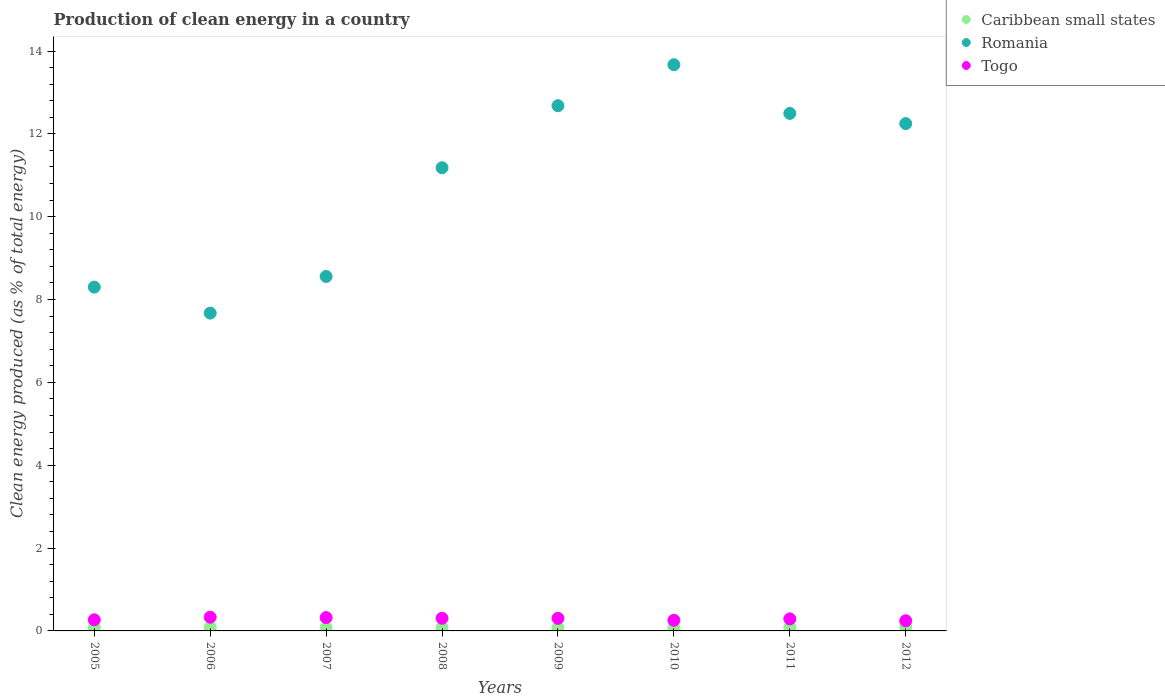Is the number of dotlines equal to the number of legend labels?
Provide a short and direct response. Yes. What is the percentage of clean energy produced in Caribbean small states in 2009?
Your answer should be compact. 0.08. Across all years, what is the maximum percentage of clean energy produced in Togo?
Your answer should be compact. 0.33. Across all years, what is the minimum percentage of clean energy produced in Caribbean small states?
Provide a short and direct response. 0.08. In which year was the percentage of clean energy produced in Togo maximum?
Offer a terse response. 2006. What is the total percentage of clean energy produced in Romania in the graph?
Make the answer very short. 86.8. What is the difference between the percentage of clean energy produced in Romania in 2008 and that in 2012?
Your answer should be compact. -1.07. What is the difference between the percentage of clean energy produced in Togo in 2005 and the percentage of clean energy produced in Caribbean small states in 2008?
Give a very brief answer. 0.19. What is the average percentage of clean energy produced in Caribbean small states per year?
Offer a very short reply. 0.09. In the year 2006, what is the difference between the percentage of clean energy produced in Romania and percentage of clean energy produced in Caribbean small states?
Offer a terse response. 7.59. In how many years, is the percentage of clean energy produced in Caribbean small states greater than 8.4 %?
Provide a short and direct response. 0. What is the ratio of the percentage of clean energy produced in Caribbean small states in 2008 to that in 2011?
Provide a succinct answer. 0.87. Is the difference between the percentage of clean energy produced in Romania in 2006 and 2008 greater than the difference between the percentage of clean energy produced in Caribbean small states in 2006 and 2008?
Your answer should be compact. No. What is the difference between the highest and the second highest percentage of clean energy produced in Romania?
Provide a succinct answer. 0.99. What is the difference between the highest and the lowest percentage of clean energy produced in Romania?
Provide a short and direct response. 6. In how many years, is the percentage of clean energy produced in Togo greater than the average percentage of clean energy produced in Togo taken over all years?
Give a very brief answer. 5. Does the percentage of clean energy produced in Romania monotonically increase over the years?
Provide a short and direct response. No. What is the difference between two consecutive major ticks on the Y-axis?
Keep it short and to the point. 2. Are the values on the major ticks of Y-axis written in scientific E-notation?
Provide a succinct answer. No. Where does the legend appear in the graph?
Provide a short and direct response. Top right. How many legend labels are there?
Ensure brevity in your answer.  3. How are the legend labels stacked?
Offer a very short reply. Vertical. What is the title of the graph?
Offer a terse response. Production of clean energy in a country. What is the label or title of the X-axis?
Ensure brevity in your answer.  Years. What is the label or title of the Y-axis?
Your answer should be very brief. Clean energy produced (as % of total energy). What is the Clean energy produced (as % of total energy) in Caribbean small states in 2005?
Provide a short and direct response. 0.09. What is the Clean energy produced (as % of total energy) of Romania in 2005?
Offer a terse response. 8.3. What is the Clean energy produced (as % of total energy) in Togo in 2005?
Keep it short and to the point. 0.27. What is the Clean energy produced (as % of total energy) of Caribbean small states in 2006?
Ensure brevity in your answer.  0.09. What is the Clean energy produced (as % of total energy) of Romania in 2006?
Offer a terse response. 7.67. What is the Clean energy produced (as % of total energy) in Togo in 2006?
Keep it short and to the point. 0.33. What is the Clean energy produced (as % of total energy) in Caribbean small states in 2007?
Your answer should be compact. 0.08. What is the Clean energy produced (as % of total energy) in Romania in 2007?
Provide a short and direct response. 8.56. What is the Clean energy produced (as % of total energy) of Togo in 2007?
Keep it short and to the point. 0.32. What is the Clean energy produced (as % of total energy) in Caribbean small states in 2008?
Give a very brief answer. 0.08. What is the Clean energy produced (as % of total energy) of Romania in 2008?
Your answer should be compact. 11.18. What is the Clean energy produced (as % of total energy) in Togo in 2008?
Ensure brevity in your answer.  0.31. What is the Clean energy produced (as % of total energy) of Caribbean small states in 2009?
Offer a terse response. 0.08. What is the Clean energy produced (as % of total energy) of Romania in 2009?
Offer a terse response. 12.68. What is the Clean energy produced (as % of total energy) in Togo in 2009?
Offer a terse response. 0.3. What is the Clean energy produced (as % of total energy) in Caribbean small states in 2010?
Keep it short and to the point. 0.08. What is the Clean energy produced (as % of total energy) in Romania in 2010?
Give a very brief answer. 13.67. What is the Clean energy produced (as % of total energy) of Togo in 2010?
Your answer should be compact. 0.26. What is the Clean energy produced (as % of total energy) in Caribbean small states in 2011?
Give a very brief answer. 0.09. What is the Clean energy produced (as % of total energy) of Romania in 2011?
Ensure brevity in your answer.  12.49. What is the Clean energy produced (as % of total energy) in Togo in 2011?
Offer a terse response. 0.29. What is the Clean energy produced (as % of total energy) in Caribbean small states in 2012?
Provide a short and direct response. 0.1. What is the Clean energy produced (as % of total energy) in Romania in 2012?
Your answer should be compact. 12.25. What is the Clean energy produced (as % of total energy) in Togo in 2012?
Your answer should be compact. 0.25. Across all years, what is the maximum Clean energy produced (as % of total energy) in Caribbean small states?
Keep it short and to the point. 0.1. Across all years, what is the maximum Clean energy produced (as % of total energy) of Romania?
Your response must be concise. 13.67. Across all years, what is the maximum Clean energy produced (as % of total energy) of Togo?
Give a very brief answer. 0.33. Across all years, what is the minimum Clean energy produced (as % of total energy) of Caribbean small states?
Give a very brief answer. 0.08. Across all years, what is the minimum Clean energy produced (as % of total energy) of Romania?
Your answer should be very brief. 7.67. Across all years, what is the minimum Clean energy produced (as % of total energy) in Togo?
Keep it short and to the point. 0.25. What is the total Clean energy produced (as % of total energy) of Caribbean small states in the graph?
Ensure brevity in your answer.  0.68. What is the total Clean energy produced (as % of total energy) in Romania in the graph?
Give a very brief answer. 86.8. What is the total Clean energy produced (as % of total energy) of Togo in the graph?
Keep it short and to the point. 2.32. What is the difference between the Clean energy produced (as % of total energy) of Caribbean small states in 2005 and that in 2006?
Keep it short and to the point. 0. What is the difference between the Clean energy produced (as % of total energy) in Romania in 2005 and that in 2006?
Make the answer very short. 0.63. What is the difference between the Clean energy produced (as % of total energy) in Togo in 2005 and that in 2006?
Make the answer very short. -0.06. What is the difference between the Clean energy produced (as % of total energy) of Caribbean small states in 2005 and that in 2007?
Keep it short and to the point. 0.01. What is the difference between the Clean energy produced (as % of total energy) of Romania in 2005 and that in 2007?
Your response must be concise. -0.26. What is the difference between the Clean energy produced (as % of total energy) of Togo in 2005 and that in 2007?
Offer a very short reply. -0.05. What is the difference between the Clean energy produced (as % of total energy) of Caribbean small states in 2005 and that in 2008?
Keep it short and to the point. 0.01. What is the difference between the Clean energy produced (as % of total energy) in Romania in 2005 and that in 2008?
Your answer should be compact. -2.88. What is the difference between the Clean energy produced (as % of total energy) of Togo in 2005 and that in 2008?
Provide a succinct answer. -0.04. What is the difference between the Clean energy produced (as % of total energy) of Caribbean small states in 2005 and that in 2009?
Make the answer very short. 0.01. What is the difference between the Clean energy produced (as % of total energy) of Romania in 2005 and that in 2009?
Your response must be concise. -4.38. What is the difference between the Clean energy produced (as % of total energy) in Togo in 2005 and that in 2009?
Provide a short and direct response. -0.04. What is the difference between the Clean energy produced (as % of total energy) in Caribbean small states in 2005 and that in 2010?
Provide a succinct answer. 0.01. What is the difference between the Clean energy produced (as % of total energy) in Romania in 2005 and that in 2010?
Your answer should be very brief. -5.37. What is the difference between the Clean energy produced (as % of total energy) of Togo in 2005 and that in 2010?
Your answer should be compact. 0.01. What is the difference between the Clean energy produced (as % of total energy) in Caribbean small states in 2005 and that in 2011?
Offer a terse response. -0. What is the difference between the Clean energy produced (as % of total energy) in Romania in 2005 and that in 2011?
Keep it short and to the point. -4.19. What is the difference between the Clean energy produced (as % of total energy) in Togo in 2005 and that in 2011?
Give a very brief answer. -0.02. What is the difference between the Clean energy produced (as % of total energy) of Caribbean small states in 2005 and that in 2012?
Offer a terse response. -0.01. What is the difference between the Clean energy produced (as % of total energy) of Romania in 2005 and that in 2012?
Offer a very short reply. -3.95. What is the difference between the Clean energy produced (as % of total energy) in Togo in 2005 and that in 2012?
Your answer should be compact. 0.02. What is the difference between the Clean energy produced (as % of total energy) in Caribbean small states in 2006 and that in 2007?
Give a very brief answer. 0.01. What is the difference between the Clean energy produced (as % of total energy) in Romania in 2006 and that in 2007?
Offer a very short reply. -0.88. What is the difference between the Clean energy produced (as % of total energy) in Togo in 2006 and that in 2007?
Provide a succinct answer. 0.01. What is the difference between the Clean energy produced (as % of total energy) in Caribbean small states in 2006 and that in 2008?
Make the answer very short. 0.01. What is the difference between the Clean energy produced (as % of total energy) of Romania in 2006 and that in 2008?
Your response must be concise. -3.51. What is the difference between the Clean energy produced (as % of total energy) in Togo in 2006 and that in 2008?
Provide a short and direct response. 0.03. What is the difference between the Clean energy produced (as % of total energy) of Caribbean small states in 2006 and that in 2009?
Keep it short and to the point. 0.01. What is the difference between the Clean energy produced (as % of total energy) in Romania in 2006 and that in 2009?
Give a very brief answer. -5.01. What is the difference between the Clean energy produced (as % of total energy) in Togo in 2006 and that in 2009?
Provide a short and direct response. 0.03. What is the difference between the Clean energy produced (as % of total energy) of Caribbean small states in 2006 and that in 2010?
Provide a short and direct response. 0.01. What is the difference between the Clean energy produced (as % of total energy) of Romania in 2006 and that in 2010?
Provide a succinct answer. -6. What is the difference between the Clean energy produced (as % of total energy) of Togo in 2006 and that in 2010?
Your answer should be compact. 0.07. What is the difference between the Clean energy produced (as % of total energy) of Caribbean small states in 2006 and that in 2011?
Keep it short and to the point. -0.01. What is the difference between the Clean energy produced (as % of total energy) of Romania in 2006 and that in 2011?
Your response must be concise. -4.82. What is the difference between the Clean energy produced (as % of total energy) in Togo in 2006 and that in 2011?
Keep it short and to the point. 0.04. What is the difference between the Clean energy produced (as % of total energy) in Caribbean small states in 2006 and that in 2012?
Provide a succinct answer. -0.01. What is the difference between the Clean energy produced (as % of total energy) of Romania in 2006 and that in 2012?
Provide a succinct answer. -4.57. What is the difference between the Clean energy produced (as % of total energy) of Togo in 2006 and that in 2012?
Keep it short and to the point. 0.09. What is the difference between the Clean energy produced (as % of total energy) in Caribbean small states in 2007 and that in 2008?
Your answer should be compact. -0. What is the difference between the Clean energy produced (as % of total energy) of Romania in 2007 and that in 2008?
Your response must be concise. -2.63. What is the difference between the Clean energy produced (as % of total energy) of Togo in 2007 and that in 2008?
Keep it short and to the point. 0.02. What is the difference between the Clean energy produced (as % of total energy) of Caribbean small states in 2007 and that in 2009?
Offer a very short reply. -0. What is the difference between the Clean energy produced (as % of total energy) of Romania in 2007 and that in 2009?
Provide a succinct answer. -4.12. What is the difference between the Clean energy produced (as % of total energy) of Togo in 2007 and that in 2009?
Make the answer very short. 0.02. What is the difference between the Clean energy produced (as % of total energy) of Caribbean small states in 2007 and that in 2010?
Your response must be concise. 0. What is the difference between the Clean energy produced (as % of total energy) of Romania in 2007 and that in 2010?
Provide a short and direct response. -5.11. What is the difference between the Clean energy produced (as % of total energy) of Togo in 2007 and that in 2010?
Keep it short and to the point. 0.07. What is the difference between the Clean energy produced (as % of total energy) in Caribbean small states in 2007 and that in 2011?
Provide a short and direct response. -0.01. What is the difference between the Clean energy produced (as % of total energy) in Romania in 2007 and that in 2011?
Make the answer very short. -3.94. What is the difference between the Clean energy produced (as % of total energy) in Togo in 2007 and that in 2011?
Your answer should be compact. 0.03. What is the difference between the Clean energy produced (as % of total energy) in Caribbean small states in 2007 and that in 2012?
Offer a terse response. -0.02. What is the difference between the Clean energy produced (as % of total energy) of Romania in 2007 and that in 2012?
Offer a very short reply. -3.69. What is the difference between the Clean energy produced (as % of total energy) of Togo in 2007 and that in 2012?
Keep it short and to the point. 0.08. What is the difference between the Clean energy produced (as % of total energy) of Caribbean small states in 2008 and that in 2009?
Ensure brevity in your answer.  0. What is the difference between the Clean energy produced (as % of total energy) of Romania in 2008 and that in 2009?
Provide a succinct answer. -1.5. What is the difference between the Clean energy produced (as % of total energy) of Togo in 2008 and that in 2009?
Keep it short and to the point. 0. What is the difference between the Clean energy produced (as % of total energy) of Caribbean small states in 2008 and that in 2010?
Provide a succinct answer. 0. What is the difference between the Clean energy produced (as % of total energy) of Romania in 2008 and that in 2010?
Offer a terse response. -2.49. What is the difference between the Clean energy produced (as % of total energy) in Togo in 2008 and that in 2010?
Offer a terse response. 0.05. What is the difference between the Clean energy produced (as % of total energy) of Caribbean small states in 2008 and that in 2011?
Provide a short and direct response. -0.01. What is the difference between the Clean energy produced (as % of total energy) of Romania in 2008 and that in 2011?
Your answer should be very brief. -1.31. What is the difference between the Clean energy produced (as % of total energy) of Togo in 2008 and that in 2011?
Your answer should be compact. 0.01. What is the difference between the Clean energy produced (as % of total energy) of Caribbean small states in 2008 and that in 2012?
Provide a short and direct response. -0.02. What is the difference between the Clean energy produced (as % of total energy) in Romania in 2008 and that in 2012?
Make the answer very short. -1.07. What is the difference between the Clean energy produced (as % of total energy) in Togo in 2008 and that in 2012?
Ensure brevity in your answer.  0.06. What is the difference between the Clean energy produced (as % of total energy) in Romania in 2009 and that in 2010?
Give a very brief answer. -0.99. What is the difference between the Clean energy produced (as % of total energy) in Togo in 2009 and that in 2010?
Provide a short and direct response. 0.05. What is the difference between the Clean energy produced (as % of total energy) of Caribbean small states in 2009 and that in 2011?
Your answer should be very brief. -0.01. What is the difference between the Clean energy produced (as % of total energy) in Romania in 2009 and that in 2011?
Provide a short and direct response. 0.19. What is the difference between the Clean energy produced (as % of total energy) of Togo in 2009 and that in 2011?
Provide a succinct answer. 0.01. What is the difference between the Clean energy produced (as % of total energy) of Caribbean small states in 2009 and that in 2012?
Your answer should be compact. -0.02. What is the difference between the Clean energy produced (as % of total energy) in Romania in 2009 and that in 2012?
Ensure brevity in your answer.  0.43. What is the difference between the Clean energy produced (as % of total energy) in Togo in 2009 and that in 2012?
Offer a terse response. 0.06. What is the difference between the Clean energy produced (as % of total energy) in Caribbean small states in 2010 and that in 2011?
Your response must be concise. -0.01. What is the difference between the Clean energy produced (as % of total energy) of Romania in 2010 and that in 2011?
Ensure brevity in your answer.  1.18. What is the difference between the Clean energy produced (as % of total energy) in Togo in 2010 and that in 2011?
Ensure brevity in your answer.  -0.03. What is the difference between the Clean energy produced (as % of total energy) in Caribbean small states in 2010 and that in 2012?
Your answer should be compact. -0.02. What is the difference between the Clean energy produced (as % of total energy) of Romania in 2010 and that in 2012?
Give a very brief answer. 1.42. What is the difference between the Clean energy produced (as % of total energy) in Togo in 2010 and that in 2012?
Your answer should be very brief. 0.01. What is the difference between the Clean energy produced (as % of total energy) of Caribbean small states in 2011 and that in 2012?
Keep it short and to the point. -0.01. What is the difference between the Clean energy produced (as % of total energy) in Romania in 2011 and that in 2012?
Provide a short and direct response. 0.25. What is the difference between the Clean energy produced (as % of total energy) of Togo in 2011 and that in 2012?
Make the answer very short. 0.05. What is the difference between the Clean energy produced (as % of total energy) of Caribbean small states in 2005 and the Clean energy produced (as % of total energy) of Romania in 2006?
Provide a succinct answer. -7.59. What is the difference between the Clean energy produced (as % of total energy) in Caribbean small states in 2005 and the Clean energy produced (as % of total energy) in Togo in 2006?
Give a very brief answer. -0.24. What is the difference between the Clean energy produced (as % of total energy) of Romania in 2005 and the Clean energy produced (as % of total energy) of Togo in 2006?
Offer a terse response. 7.97. What is the difference between the Clean energy produced (as % of total energy) in Caribbean small states in 2005 and the Clean energy produced (as % of total energy) in Romania in 2007?
Provide a short and direct response. -8.47. What is the difference between the Clean energy produced (as % of total energy) of Caribbean small states in 2005 and the Clean energy produced (as % of total energy) of Togo in 2007?
Keep it short and to the point. -0.23. What is the difference between the Clean energy produced (as % of total energy) of Romania in 2005 and the Clean energy produced (as % of total energy) of Togo in 2007?
Your response must be concise. 7.98. What is the difference between the Clean energy produced (as % of total energy) of Caribbean small states in 2005 and the Clean energy produced (as % of total energy) of Romania in 2008?
Your answer should be compact. -11.09. What is the difference between the Clean energy produced (as % of total energy) of Caribbean small states in 2005 and the Clean energy produced (as % of total energy) of Togo in 2008?
Provide a short and direct response. -0.22. What is the difference between the Clean energy produced (as % of total energy) of Romania in 2005 and the Clean energy produced (as % of total energy) of Togo in 2008?
Provide a short and direct response. 7.99. What is the difference between the Clean energy produced (as % of total energy) of Caribbean small states in 2005 and the Clean energy produced (as % of total energy) of Romania in 2009?
Ensure brevity in your answer.  -12.59. What is the difference between the Clean energy produced (as % of total energy) in Caribbean small states in 2005 and the Clean energy produced (as % of total energy) in Togo in 2009?
Keep it short and to the point. -0.22. What is the difference between the Clean energy produced (as % of total energy) in Romania in 2005 and the Clean energy produced (as % of total energy) in Togo in 2009?
Ensure brevity in your answer.  8. What is the difference between the Clean energy produced (as % of total energy) of Caribbean small states in 2005 and the Clean energy produced (as % of total energy) of Romania in 2010?
Your answer should be compact. -13.58. What is the difference between the Clean energy produced (as % of total energy) in Caribbean small states in 2005 and the Clean energy produced (as % of total energy) in Togo in 2010?
Provide a short and direct response. -0.17. What is the difference between the Clean energy produced (as % of total energy) of Romania in 2005 and the Clean energy produced (as % of total energy) of Togo in 2010?
Offer a very short reply. 8.04. What is the difference between the Clean energy produced (as % of total energy) of Caribbean small states in 2005 and the Clean energy produced (as % of total energy) of Romania in 2011?
Your response must be concise. -12.41. What is the difference between the Clean energy produced (as % of total energy) in Caribbean small states in 2005 and the Clean energy produced (as % of total energy) in Togo in 2011?
Provide a succinct answer. -0.2. What is the difference between the Clean energy produced (as % of total energy) in Romania in 2005 and the Clean energy produced (as % of total energy) in Togo in 2011?
Make the answer very short. 8.01. What is the difference between the Clean energy produced (as % of total energy) in Caribbean small states in 2005 and the Clean energy produced (as % of total energy) in Romania in 2012?
Offer a terse response. -12.16. What is the difference between the Clean energy produced (as % of total energy) of Caribbean small states in 2005 and the Clean energy produced (as % of total energy) of Togo in 2012?
Keep it short and to the point. -0.16. What is the difference between the Clean energy produced (as % of total energy) in Romania in 2005 and the Clean energy produced (as % of total energy) in Togo in 2012?
Provide a short and direct response. 8.05. What is the difference between the Clean energy produced (as % of total energy) in Caribbean small states in 2006 and the Clean energy produced (as % of total energy) in Romania in 2007?
Your answer should be compact. -8.47. What is the difference between the Clean energy produced (as % of total energy) of Caribbean small states in 2006 and the Clean energy produced (as % of total energy) of Togo in 2007?
Provide a short and direct response. -0.24. What is the difference between the Clean energy produced (as % of total energy) in Romania in 2006 and the Clean energy produced (as % of total energy) in Togo in 2007?
Make the answer very short. 7.35. What is the difference between the Clean energy produced (as % of total energy) of Caribbean small states in 2006 and the Clean energy produced (as % of total energy) of Romania in 2008?
Offer a terse response. -11.1. What is the difference between the Clean energy produced (as % of total energy) in Caribbean small states in 2006 and the Clean energy produced (as % of total energy) in Togo in 2008?
Your answer should be very brief. -0.22. What is the difference between the Clean energy produced (as % of total energy) of Romania in 2006 and the Clean energy produced (as % of total energy) of Togo in 2008?
Your answer should be compact. 7.37. What is the difference between the Clean energy produced (as % of total energy) of Caribbean small states in 2006 and the Clean energy produced (as % of total energy) of Romania in 2009?
Give a very brief answer. -12.59. What is the difference between the Clean energy produced (as % of total energy) in Caribbean small states in 2006 and the Clean energy produced (as % of total energy) in Togo in 2009?
Ensure brevity in your answer.  -0.22. What is the difference between the Clean energy produced (as % of total energy) of Romania in 2006 and the Clean energy produced (as % of total energy) of Togo in 2009?
Your answer should be very brief. 7.37. What is the difference between the Clean energy produced (as % of total energy) of Caribbean small states in 2006 and the Clean energy produced (as % of total energy) of Romania in 2010?
Give a very brief answer. -13.58. What is the difference between the Clean energy produced (as % of total energy) of Caribbean small states in 2006 and the Clean energy produced (as % of total energy) of Togo in 2010?
Ensure brevity in your answer.  -0.17. What is the difference between the Clean energy produced (as % of total energy) of Romania in 2006 and the Clean energy produced (as % of total energy) of Togo in 2010?
Offer a terse response. 7.42. What is the difference between the Clean energy produced (as % of total energy) of Caribbean small states in 2006 and the Clean energy produced (as % of total energy) of Romania in 2011?
Your answer should be compact. -12.41. What is the difference between the Clean energy produced (as % of total energy) in Caribbean small states in 2006 and the Clean energy produced (as % of total energy) in Togo in 2011?
Your answer should be compact. -0.21. What is the difference between the Clean energy produced (as % of total energy) of Romania in 2006 and the Clean energy produced (as % of total energy) of Togo in 2011?
Keep it short and to the point. 7.38. What is the difference between the Clean energy produced (as % of total energy) in Caribbean small states in 2006 and the Clean energy produced (as % of total energy) in Romania in 2012?
Your answer should be very brief. -12.16. What is the difference between the Clean energy produced (as % of total energy) in Caribbean small states in 2006 and the Clean energy produced (as % of total energy) in Togo in 2012?
Provide a short and direct response. -0.16. What is the difference between the Clean energy produced (as % of total energy) in Romania in 2006 and the Clean energy produced (as % of total energy) in Togo in 2012?
Your answer should be compact. 7.43. What is the difference between the Clean energy produced (as % of total energy) in Caribbean small states in 2007 and the Clean energy produced (as % of total energy) in Romania in 2008?
Your response must be concise. -11.1. What is the difference between the Clean energy produced (as % of total energy) in Caribbean small states in 2007 and the Clean energy produced (as % of total energy) in Togo in 2008?
Give a very brief answer. -0.23. What is the difference between the Clean energy produced (as % of total energy) in Romania in 2007 and the Clean energy produced (as % of total energy) in Togo in 2008?
Provide a short and direct response. 8.25. What is the difference between the Clean energy produced (as % of total energy) in Caribbean small states in 2007 and the Clean energy produced (as % of total energy) in Romania in 2009?
Ensure brevity in your answer.  -12.6. What is the difference between the Clean energy produced (as % of total energy) in Caribbean small states in 2007 and the Clean energy produced (as % of total energy) in Togo in 2009?
Provide a short and direct response. -0.23. What is the difference between the Clean energy produced (as % of total energy) of Romania in 2007 and the Clean energy produced (as % of total energy) of Togo in 2009?
Provide a succinct answer. 8.25. What is the difference between the Clean energy produced (as % of total energy) of Caribbean small states in 2007 and the Clean energy produced (as % of total energy) of Romania in 2010?
Your answer should be compact. -13.59. What is the difference between the Clean energy produced (as % of total energy) in Caribbean small states in 2007 and the Clean energy produced (as % of total energy) in Togo in 2010?
Your response must be concise. -0.18. What is the difference between the Clean energy produced (as % of total energy) in Romania in 2007 and the Clean energy produced (as % of total energy) in Togo in 2010?
Provide a short and direct response. 8.3. What is the difference between the Clean energy produced (as % of total energy) in Caribbean small states in 2007 and the Clean energy produced (as % of total energy) in Romania in 2011?
Keep it short and to the point. -12.42. What is the difference between the Clean energy produced (as % of total energy) in Caribbean small states in 2007 and the Clean energy produced (as % of total energy) in Togo in 2011?
Ensure brevity in your answer.  -0.21. What is the difference between the Clean energy produced (as % of total energy) in Romania in 2007 and the Clean energy produced (as % of total energy) in Togo in 2011?
Your response must be concise. 8.27. What is the difference between the Clean energy produced (as % of total energy) in Caribbean small states in 2007 and the Clean energy produced (as % of total energy) in Romania in 2012?
Ensure brevity in your answer.  -12.17. What is the difference between the Clean energy produced (as % of total energy) of Caribbean small states in 2007 and the Clean energy produced (as % of total energy) of Togo in 2012?
Offer a very short reply. -0.17. What is the difference between the Clean energy produced (as % of total energy) in Romania in 2007 and the Clean energy produced (as % of total energy) in Togo in 2012?
Keep it short and to the point. 8.31. What is the difference between the Clean energy produced (as % of total energy) of Caribbean small states in 2008 and the Clean energy produced (as % of total energy) of Romania in 2009?
Your answer should be very brief. -12.6. What is the difference between the Clean energy produced (as % of total energy) of Caribbean small states in 2008 and the Clean energy produced (as % of total energy) of Togo in 2009?
Make the answer very short. -0.22. What is the difference between the Clean energy produced (as % of total energy) of Romania in 2008 and the Clean energy produced (as % of total energy) of Togo in 2009?
Make the answer very short. 10.88. What is the difference between the Clean energy produced (as % of total energy) of Caribbean small states in 2008 and the Clean energy produced (as % of total energy) of Romania in 2010?
Offer a very short reply. -13.59. What is the difference between the Clean energy produced (as % of total energy) in Caribbean small states in 2008 and the Clean energy produced (as % of total energy) in Togo in 2010?
Give a very brief answer. -0.18. What is the difference between the Clean energy produced (as % of total energy) of Romania in 2008 and the Clean energy produced (as % of total energy) of Togo in 2010?
Ensure brevity in your answer.  10.93. What is the difference between the Clean energy produced (as % of total energy) of Caribbean small states in 2008 and the Clean energy produced (as % of total energy) of Romania in 2011?
Provide a succinct answer. -12.41. What is the difference between the Clean energy produced (as % of total energy) in Caribbean small states in 2008 and the Clean energy produced (as % of total energy) in Togo in 2011?
Give a very brief answer. -0.21. What is the difference between the Clean energy produced (as % of total energy) of Romania in 2008 and the Clean energy produced (as % of total energy) of Togo in 2011?
Your answer should be compact. 10.89. What is the difference between the Clean energy produced (as % of total energy) of Caribbean small states in 2008 and the Clean energy produced (as % of total energy) of Romania in 2012?
Keep it short and to the point. -12.17. What is the difference between the Clean energy produced (as % of total energy) in Caribbean small states in 2008 and the Clean energy produced (as % of total energy) in Togo in 2012?
Provide a succinct answer. -0.16. What is the difference between the Clean energy produced (as % of total energy) in Romania in 2008 and the Clean energy produced (as % of total energy) in Togo in 2012?
Offer a terse response. 10.94. What is the difference between the Clean energy produced (as % of total energy) in Caribbean small states in 2009 and the Clean energy produced (as % of total energy) in Romania in 2010?
Your response must be concise. -13.59. What is the difference between the Clean energy produced (as % of total energy) of Caribbean small states in 2009 and the Clean energy produced (as % of total energy) of Togo in 2010?
Your answer should be compact. -0.18. What is the difference between the Clean energy produced (as % of total energy) of Romania in 2009 and the Clean energy produced (as % of total energy) of Togo in 2010?
Make the answer very short. 12.42. What is the difference between the Clean energy produced (as % of total energy) of Caribbean small states in 2009 and the Clean energy produced (as % of total energy) of Romania in 2011?
Offer a terse response. -12.42. What is the difference between the Clean energy produced (as % of total energy) of Caribbean small states in 2009 and the Clean energy produced (as % of total energy) of Togo in 2011?
Ensure brevity in your answer.  -0.21. What is the difference between the Clean energy produced (as % of total energy) of Romania in 2009 and the Clean energy produced (as % of total energy) of Togo in 2011?
Give a very brief answer. 12.39. What is the difference between the Clean energy produced (as % of total energy) of Caribbean small states in 2009 and the Clean energy produced (as % of total energy) of Romania in 2012?
Make the answer very short. -12.17. What is the difference between the Clean energy produced (as % of total energy) in Caribbean small states in 2009 and the Clean energy produced (as % of total energy) in Togo in 2012?
Offer a very short reply. -0.17. What is the difference between the Clean energy produced (as % of total energy) of Romania in 2009 and the Clean energy produced (as % of total energy) of Togo in 2012?
Make the answer very short. 12.43. What is the difference between the Clean energy produced (as % of total energy) of Caribbean small states in 2010 and the Clean energy produced (as % of total energy) of Romania in 2011?
Your answer should be compact. -12.42. What is the difference between the Clean energy produced (as % of total energy) in Caribbean small states in 2010 and the Clean energy produced (as % of total energy) in Togo in 2011?
Provide a short and direct response. -0.21. What is the difference between the Clean energy produced (as % of total energy) in Romania in 2010 and the Clean energy produced (as % of total energy) in Togo in 2011?
Give a very brief answer. 13.38. What is the difference between the Clean energy produced (as % of total energy) in Caribbean small states in 2010 and the Clean energy produced (as % of total energy) in Romania in 2012?
Your answer should be very brief. -12.17. What is the difference between the Clean energy produced (as % of total energy) of Caribbean small states in 2010 and the Clean energy produced (as % of total energy) of Togo in 2012?
Keep it short and to the point. -0.17. What is the difference between the Clean energy produced (as % of total energy) of Romania in 2010 and the Clean energy produced (as % of total energy) of Togo in 2012?
Make the answer very short. 13.42. What is the difference between the Clean energy produced (as % of total energy) in Caribbean small states in 2011 and the Clean energy produced (as % of total energy) in Romania in 2012?
Give a very brief answer. -12.16. What is the difference between the Clean energy produced (as % of total energy) in Caribbean small states in 2011 and the Clean energy produced (as % of total energy) in Togo in 2012?
Give a very brief answer. -0.15. What is the difference between the Clean energy produced (as % of total energy) of Romania in 2011 and the Clean energy produced (as % of total energy) of Togo in 2012?
Keep it short and to the point. 12.25. What is the average Clean energy produced (as % of total energy) in Caribbean small states per year?
Your answer should be compact. 0.09. What is the average Clean energy produced (as % of total energy) in Romania per year?
Your response must be concise. 10.85. What is the average Clean energy produced (as % of total energy) of Togo per year?
Give a very brief answer. 0.29. In the year 2005, what is the difference between the Clean energy produced (as % of total energy) in Caribbean small states and Clean energy produced (as % of total energy) in Romania?
Make the answer very short. -8.21. In the year 2005, what is the difference between the Clean energy produced (as % of total energy) in Caribbean small states and Clean energy produced (as % of total energy) in Togo?
Offer a very short reply. -0.18. In the year 2005, what is the difference between the Clean energy produced (as % of total energy) of Romania and Clean energy produced (as % of total energy) of Togo?
Keep it short and to the point. 8.03. In the year 2006, what is the difference between the Clean energy produced (as % of total energy) in Caribbean small states and Clean energy produced (as % of total energy) in Romania?
Ensure brevity in your answer.  -7.59. In the year 2006, what is the difference between the Clean energy produced (as % of total energy) of Caribbean small states and Clean energy produced (as % of total energy) of Togo?
Keep it short and to the point. -0.24. In the year 2006, what is the difference between the Clean energy produced (as % of total energy) of Romania and Clean energy produced (as % of total energy) of Togo?
Your response must be concise. 7.34. In the year 2007, what is the difference between the Clean energy produced (as % of total energy) of Caribbean small states and Clean energy produced (as % of total energy) of Romania?
Your answer should be very brief. -8.48. In the year 2007, what is the difference between the Clean energy produced (as % of total energy) of Caribbean small states and Clean energy produced (as % of total energy) of Togo?
Offer a terse response. -0.24. In the year 2007, what is the difference between the Clean energy produced (as % of total energy) in Romania and Clean energy produced (as % of total energy) in Togo?
Your answer should be compact. 8.23. In the year 2008, what is the difference between the Clean energy produced (as % of total energy) of Caribbean small states and Clean energy produced (as % of total energy) of Romania?
Offer a very short reply. -11.1. In the year 2008, what is the difference between the Clean energy produced (as % of total energy) in Caribbean small states and Clean energy produced (as % of total energy) in Togo?
Offer a terse response. -0.23. In the year 2008, what is the difference between the Clean energy produced (as % of total energy) in Romania and Clean energy produced (as % of total energy) in Togo?
Your answer should be very brief. 10.88. In the year 2009, what is the difference between the Clean energy produced (as % of total energy) of Caribbean small states and Clean energy produced (as % of total energy) of Romania?
Ensure brevity in your answer.  -12.6. In the year 2009, what is the difference between the Clean energy produced (as % of total energy) in Caribbean small states and Clean energy produced (as % of total energy) in Togo?
Make the answer very short. -0.23. In the year 2009, what is the difference between the Clean energy produced (as % of total energy) in Romania and Clean energy produced (as % of total energy) in Togo?
Give a very brief answer. 12.38. In the year 2010, what is the difference between the Clean energy produced (as % of total energy) in Caribbean small states and Clean energy produced (as % of total energy) in Romania?
Your response must be concise. -13.59. In the year 2010, what is the difference between the Clean energy produced (as % of total energy) of Caribbean small states and Clean energy produced (as % of total energy) of Togo?
Offer a very short reply. -0.18. In the year 2010, what is the difference between the Clean energy produced (as % of total energy) in Romania and Clean energy produced (as % of total energy) in Togo?
Offer a very short reply. 13.41. In the year 2011, what is the difference between the Clean energy produced (as % of total energy) in Caribbean small states and Clean energy produced (as % of total energy) in Romania?
Offer a very short reply. -12.4. In the year 2011, what is the difference between the Clean energy produced (as % of total energy) in Caribbean small states and Clean energy produced (as % of total energy) in Togo?
Keep it short and to the point. -0.2. In the year 2011, what is the difference between the Clean energy produced (as % of total energy) of Romania and Clean energy produced (as % of total energy) of Togo?
Provide a succinct answer. 12.2. In the year 2012, what is the difference between the Clean energy produced (as % of total energy) of Caribbean small states and Clean energy produced (as % of total energy) of Romania?
Ensure brevity in your answer.  -12.15. In the year 2012, what is the difference between the Clean energy produced (as % of total energy) in Caribbean small states and Clean energy produced (as % of total energy) in Togo?
Give a very brief answer. -0.14. In the year 2012, what is the difference between the Clean energy produced (as % of total energy) of Romania and Clean energy produced (as % of total energy) of Togo?
Offer a very short reply. 12. What is the ratio of the Clean energy produced (as % of total energy) in Caribbean small states in 2005 to that in 2006?
Offer a terse response. 1.02. What is the ratio of the Clean energy produced (as % of total energy) of Romania in 2005 to that in 2006?
Make the answer very short. 1.08. What is the ratio of the Clean energy produced (as % of total energy) of Togo in 2005 to that in 2006?
Provide a short and direct response. 0.81. What is the ratio of the Clean energy produced (as % of total energy) in Caribbean small states in 2005 to that in 2007?
Offer a very short reply. 1.12. What is the ratio of the Clean energy produced (as % of total energy) of Romania in 2005 to that in 2007?
Provide a succinct answer. 0.97. What is the ratio of the Clean energy produced (as % of total energy) in Togo in 2005 to that in 2007?
Your answer should be very brief. 0.83. What is the ratio of the Clean energy produced (as % of total energy) in Caribbean small states in 2005 to that in 2008?
Provide a succinct answer. 1.09. What is the ratio of the Clean energy produced (as % of total energy) in Romania in 2005 to that in 2008?
Offer a very short reply. 0.74. What is the ratio of the Clean energy produced (as % of total energy) of Togo in 2005 to that in 2008?
Your answer should be very brief. 0.88. What is the ratio of the Clean energy produced (as % of total energy) in Caribbean small states in 2005 to that in 2009?
Ensure brevity in your answer.  1.12. What is the ratio of the Clean energy produced (as % of total energy) of Romania in 2005 to that in 2009?
Provide a short and direct response. 0.65. What is the ratio of the Clean energy produced (as % of total energy) of Togo in 2005 to that in 2009?
Your answer should be very brief. 0.88. What is the ratio of the Clean energy produced (as % of total energy) of Caribbean small states in 2005 to that in 2010?
Ensure brevity in your answer.  1.13. What is the ratio of the Clean energy produced (as % of total energy) in Romania in 2005 to that in 2010?
Make the answer very short. 0.61. What is the ratio of the Clean energy produced (as % of total energy) in Togo in 2005 to that in 2010?
Offer a very short reply. 1.05. What is the ratio of the Clean energy produced (as % of total energy) of Caribbean small states in 2005 to that in 2011?
Give a very brief answer. 0.95. What is the ratio of the Clean energy produced (as % of total energy) of Romania in 2005 to that in 2011?
Ensure brevity in your answer.  0.66. What is the ratio of the Clean energy produced (as % of total energy) in Togo in 2005 to that in 2011?
Ensure brevity in your answer.  0.92. What is the ratio of the Clean energy produced (as % of total energy) of Caribbean small states in 2005 to that in 2012?
Keep it short and to the point. 0.87. What is the ratio of the Clean energy produced (as % of total energy) of Romania in 2005 to that in 2012?
Your answer should be compact. 0.68. What is the ratio of the Clean energy produced (as % of total energy) in Togo in 2005 to that in 2012?
Your answer should be very brief. 1.09. What is the ratio of the Clean energy produced (as % of total energy) of Caribbean small states in 2006 to that in 2007?
Ensure brevity in your answer.  1.1. What is the ratio of the Clean energy produced (as % of total energy) of Romania in 2006 to that in 2007?
Ensure brevity in your answer.  0.9. What is the ratio of the Clean energy produced (as % of total energy) in Togo in 2006 to that in 2007?
Provide a short and direct response. 1.03. What is the ratio of the Clean energy produced (as % of total energy) of Caribbean small states in 2006 to that in 2008?
Provide a succinct answer. 1.07. What is the ratio of the Clean energy produced (as % of total energy) of Romania in 2006 to that in 2008?
Your answer should be very brief. 0.69. What is the ratio of the Clean energy produced (as % of total energy) in Togo in 2006 to that in 2008?
Your response must be concise. 1.08. What is the ratio of the Clean energy produced (as % of total energy) in Caribbean small states in 2006 to that in 2009?
Keep it short and to the point. 1.09. What is the ratio of the Clean energy produced (as % of total energy) of Romania in 2006 to that in 2009?
Offer a terse response. 0.61. What is the ratio of the Clean energy produced (as % of total energy) in Togo in 2006 to that in 2009?
Your response must be concise. 1.09. What is the ratio of the Clean energy produced (as % of total energy) in Caribbean small states in 2006 to that in 2010?
Your answer should be compact. 1.11. What is the ratio of the Clean energy produced (as % of total energy) in Romania in 2006 to that in 2010?
Your answer should be compact. 0.56. What is the ratio of the Clean energy produced (as % of total energy) of Togo in 2006 to that in 2010?
Offer a very short reply. 1.29. What is the ratio of the Clean energy produced (as % of total energy) of Caribbean small states in 2006 to that in 2011?
Make the answer very short. 0.93. What is the ratio of the Clean energy produced (as % of total energy) in Romania in 2006 to that in 2011?
Make the answer very short. 0.61. What is the ratio of the Clean energy produced (as % of total energy) of Togo in 2006 to that in 2011?
Offer a terse response. 1.14. What is the ratio of the Clean energy produced (as % of total energy) in Caribbean small states in 2006 to that in 2012?
Provide a short and direct response. 0.85. What is the ratio of the Clean energy produced (as % of total energy) of Romania in 2006 to that in 2012?
Your response must be concise. 0.63. What is the ratio of the Clean energy produced (as % of total energy) in Togo in 2006 to that in 2012?
Your response must be concise. 1.35. What is the ratio of the Clean energy produced (as % of total energy) in Caribbean small states in 2007 to that in 2008?
Give a very brief answer. 0.97. What is the ratio of the Clean energy produced (as % of total energy) of Romania in 2007 to that in 2008?
Ensure brevity in your answer.  0.77. What is the ratio of the Clean energy produced (as % of total energy) of Togo in 2007 to that in 2008?
Give a very brief answer. 1.05. What is the ratio of the Clean energy produced (as % of total energy) of Caribbean small states in 2007 to that in 2009?
Your answer should be compact. 1. What is the ratio of the Clean energy produced (as % of total energy) in Romania in 2007 to that in 2009?
Your answer should be very brief. 0.67. What is the ratio of the Clean energy produced (as % of total energy) of Togo in 2007 to that in 2009?
Offer a very short reply. 1.06. What is the ratio of the Clean energy produced (as % of total energy) of Romania in 2007 to that in 2010?
Ensure brevity in your answer.  0.63. What is the ratio of the Clean energy produced (as % of total energy) in Togo in 2007 to that in 2010?
Your answer should be compact. 1.25. What is the ratio of the Clean energy produced (as % of total energy) in Caribbean small states in 2007 to that in 2011?
Give a very brief answer. 0.85. What is the ratio of the Clean energy produced (as % of total energy) of Romania in 2007 to that in 2011?
Offer a terse response. 0.68. What is the ratio of the Clean energy produced (as % of total energy) in Togo in 2007 to that in 2011?
Give a very brief answer. 1.11. What is the ratio of the Clean energy produced (as % of total energy) of Caribbean small states in 2007 to that in 2012?
Make the answer very short. 0.78. What is the ratio of the Clean energy produced (as % of total energy) of Romania in 2007 to that in 2012?
Your answer should be very brief. 0.7. What is the ratio of the Clean energy produced (as % of total energy) of Togo in 2007 to that in 2012?
Provide a short and direct response. 1.31. What is the ratio of the Clean energy produced (as % of total energy) in Caribbean small states in 2008 to that in 2009?
Ensure brevity in your answer.  1.03. What is the ratio of the Clean energy produced (as % of total energy) of Romania in 2008 to that in 2009?
Make the answer very short. 0.88. What is the ratio of the Clean energy produced (as % of total energy) in Caribbean small states in 2008 to that in 2010?
Your answer should be compact. 1.04. What is the ratio of the Clean energy produced (as % of total energy) in Romania in 2008 to that in 2010?
Make the answer very short. 0.82. What is the ratio of the Clean energy produced (as % of total energy) of Togo in 2008 to that in 2010?
Offer a terse response. 1.19. What is the ratio of the Clean energy produced (as % of total energy) in Caribbean small states in 2008 to that in 2011?
Your answer should be compact. 0.87. What is the ratio of the Clean energy produced (as % of total energy) of Romania in 2008 to that in 2011?
Give a very brief answer. 0.9. What is the ratio of the Clean energy produced (as % of total energy) in Caribbean small states in 2008 to that in 2012?
Your answer should be very brief. 0.8. What is the ratio of the Clean energy produced (as % of total energy) in Romania in 2008 to that in 2012?
Make the answer very short. 0.91. What is the ratio of the Clean energy produced (as % of total energy) of Togo in 2008 to that in 2012?
Provide a succinct answer. 1.25. What is the ratio of the Clean energy produced (as % of total energy) of Caribbean small states in 2009 to that in 2010?
Offer a terse response. 1.01. What is the ratio of the Clean energy produced (as % of total energy) in Romania in 2009 to that in 2010?
Offer a very short reply. 0.93. What is the ratio of the Clean energy produced (as % of total energy) of Togo in 2009 to that in 2010?
Offer a terse response. 1.18. What is the ratio of the Clean energy produced (as % of total energy) of Caribbean small states in 2009 to that in 2011?
Offer a terse response. 0.85. What is the ratio of the Clean energy produced (as % of total energy) of Romania in 2009 to that in 2011?
Your answer should be compact. 1.01. What is the ratio of the Clean energy produced (as % of total energy) of Togo in 2009 to that in 2011?
Give a very brief answer. 1.04. What is the ratio of the Clean energy produced (as % of total energy) of Caribbean small states in 2009 to that in 2012?
Make the answer very short. 0.78. What is the ratio of the Clean energy produced (as % of total energy) in Romania in 2009 to that in 2012?
Provide a short and direct response. 1.04. What is the ratio of the Clean energy produced (as % of total energy) in Togo in 2009 to that in 2012?
Your answer should be compact. 1.24. What is the ratio of the Clean energy produced (as % of total energy) of Caribbean small states in 2010 to that in 2011?
Ensure brevity in your answer.  0.84. What is the ratio of the Clean energy produced (as % of total energy) in Romania in 2010 to that in 2011?
Offer a very short reply. 1.09. What is the ratio of the Clean energy produced (as % of total energy) in Togo in 2010 to that in 2011?
Your response must be concise. 0.88. What is the ratio of the Clean energy produced (as % of total energy) of Caribbean small states in 2010 to that in 2012?
Your answer should be compact. 0.77. What is the ratio of the Clean energy produced (as % of total energy) in Romania in 2010 to that in 2012?
Offer a terse response. 1.12. What is the ratio of the Clean energy produced (as % of total energy) of Togo in 2010 to that in 2012?
Provide a succinct answer. 1.05. What is the ratio of the Clean energy produced (as % of total energy) of Caribbean small states in 2011 to that in 2012?
Make the answer very short. 0.92. What is the ratio of the Clean energy produced (as % of total energy) in Romania in 2011 to that in 2012?
Give a very brief answer. 1.02. What is the ratio of the Clean energy produced (as % of total energy) in Togo in 2011 to that in 2012?
Make the answer very short. 1.19. What is the difference between the highest and the second highest Clean energy produced (as % of total energy) in Caribbean small states?
Make the answer very short. 0.01. What is the difference between the highest and the second highest Clean energy produced (as % of total energy) of Romania?
Ensure brevity in your answer.  0.99. What is the difference between the highest and the second highest Clean energy produced (as % of total energy) in Togo?
Make the answer very short. 0.01. What is the difference between the highest and the lowest Clean energy produced (as % of total energy) in Caribbean small states?
Make the answer very short. 0.02. What is the difference between the highest and the lowest Clean energy produced (as % of total energy) of Romania?
Offer a terse response. 6. What is the difference between the highest and the lowest Clean energy produced (as % of total energy) in Togo?
Offer a very short reply. 0.09. 